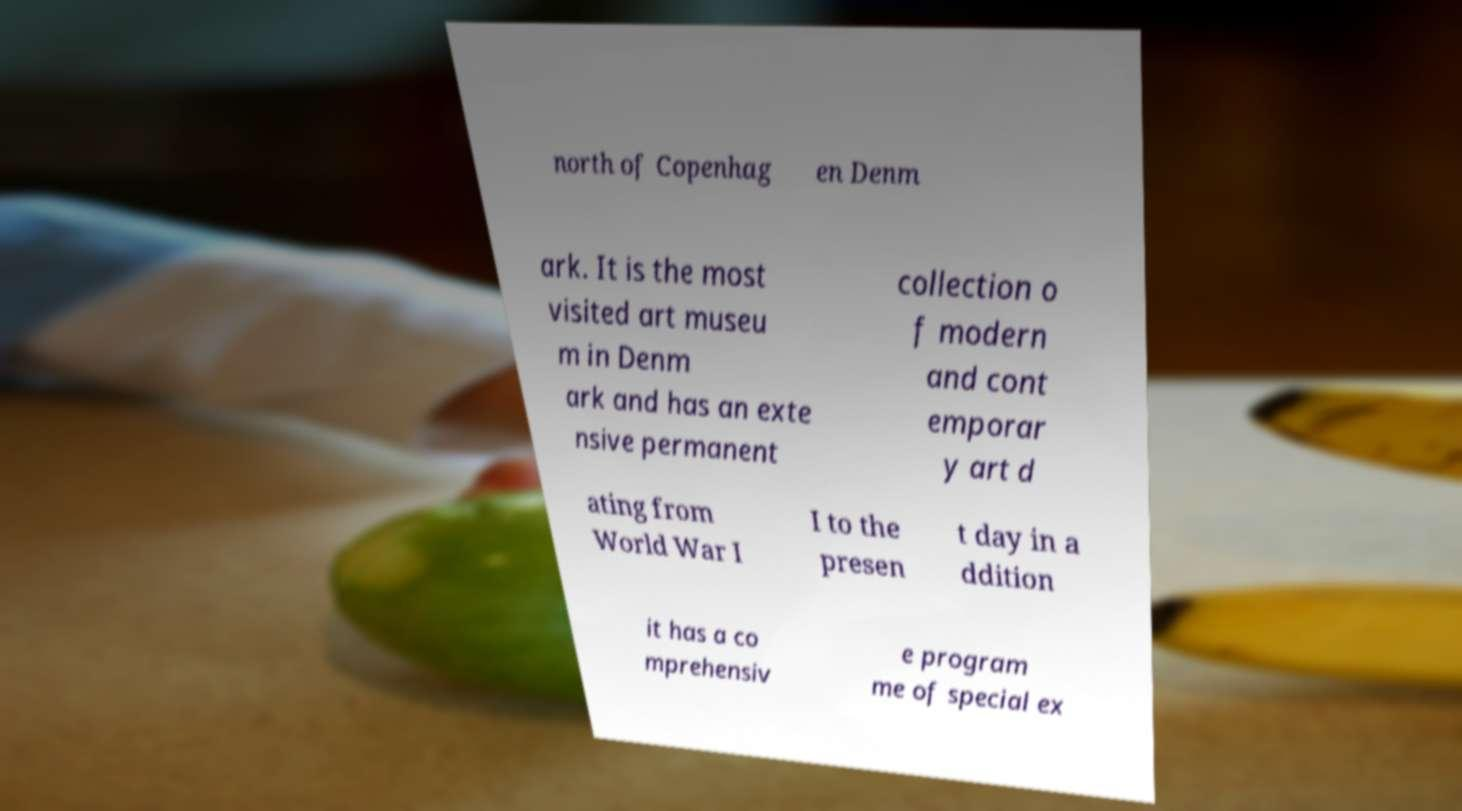Could you extract and type out the text from this image? north of Copenhag en Denm ark. It is the most visited art museu m in Denm ark and has an exte nsive permanent collection o f modern and cont emporar y art d ating from World War I I to the presen t day in a ddition it has a co mprehensiv e program me of special ex 